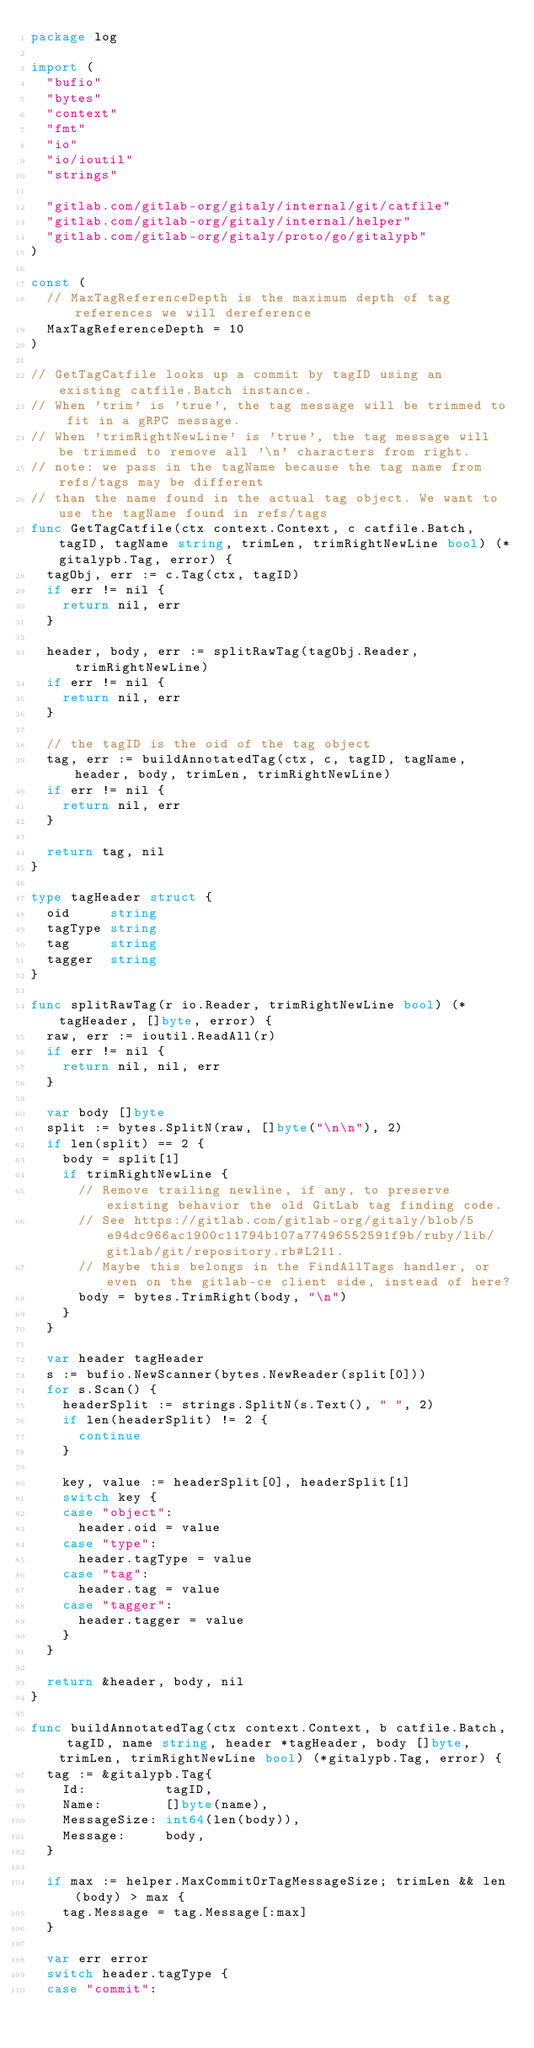<code> <loc_0><loc_0><loc_500><loc_500><_Go_>package log

import (
	"bufio"
	"bytes"
	"context"
	"fmt"
	"io"
	"io/ioutil"
	"strings"

	"gitlab.com/gitlab-org/gitaly/internal/git/catfile"
	"gitlab.com/gitlab-org/gitaly/internal/helper"
	"gitlab.com/gitlab-org/gitaly/proto/go/gitalypb"
)

const (
	// MaxTagReferenceDepth is the maximum depth of tag references we will dereference
	MaxTagReferenceDepth = 10
)

// GetTagCatfile looks up a commit by tagID using an existing catfile.Batch instance.
// When 'trim' is 'true', the tag message will be trimmed to fit in a gRPC message.
// When 'trimRightNewLine' is 'true', the tag message will be trimmed to remove all '\n' characters from right.
// note: we pass in the tagName because the tag name from refs/tags may be different
// than the name found in the actual tag object. We want to use the tagName found in refs/tags
func GetTagCatfile(ctx context.Context, c catfile.Batch, tagID, tagName string, trimLen, trimRightNewLine bool) (*gitalypb.Tag, error) {
	tagObj, err := c.Tag(ctx, tagID)
	if err != nil {
		return nil, err
	}

	header, body, err := splitRawTag(tagObj.Reader, trimRightNewLine)
	if err != nil {
		return nil, err
	}

	// the tagID is the oid of the tag object
	tag, err := buildAnnotatedTag(ctx, c, tagID, tagName, header, body, trimLen, trimRightNewLine)
	if err != nil {
		return nil, err
	}

	return tag, nil
}

type tagHeader struct {
	oid     string
	tagType string
	tag     string
	tagger  string
}

func splitRawTag(r io.Reader, trimRightNewLine bool) (*tagHeader, []byte, error) {
	raw, err := ioutil.ReadAll(r)
	if err != nil {
		return nil, nil, err
	}

	var body []byte
	split := bytes.SplitN(raw, []byte("\n\n"), 2)
	if len(split) == 2 {
		body = split[1]
		if trimRightNewLine {
			// Remove trailing newline, if any, to preserve existing behavior the old GitLab tag finding code.
			// See https://gitlab.com/gitlab-org/gitaly/blob/5e94dc966ac1900c11794b107a77496552591f9b/ruby/lib/gitlab/git/repository.rb#L211.
			// Maybe this belongs in the FindAllTags handler, or even on the gitlab-ce client side, instead of here?
			body = bytes.TrimRight(body, "\n")
		}
	}

	var header tagHeader
	s := bufio.NewScanner(bytes.NewReader(split[0]))
	for s.Scan() {
		headerSplit := strings.SplitN(s.Text(), " ", 2)
		if len(headerSplit) != 2 {
			continue
		}

		key, value := headerSplit[0], headerSplit[1]
		switch key {
		case "object":
			header.oid = value
		case "type":
			header.tagType = value
		case "tag":
			header.tag = value
		case "tagger":
			header.tagger = value
		}
	}

	return &header, body, nil
}

func buildAnnotatedTag(ctx context.Context, b catfile.Batch, tagID, name string, header *tagHeader, body []byte, trimLen, trimRightNewLine bool) (*gitalypb.Tag, error) {
	tag := &gitalypb.Tag{
		Id:          tagID,
		Name:        []byte(name),
		MessageSize: int64(len(body)),
		Message:     body,
	}

	if max := helper.MaxCommitOrTagMessageSize; trimLen && len(body) > max {
		tag.Message = tag.Message[:max]
	}

	var err error
	switch header.tagType {
	case "commit":</code> 